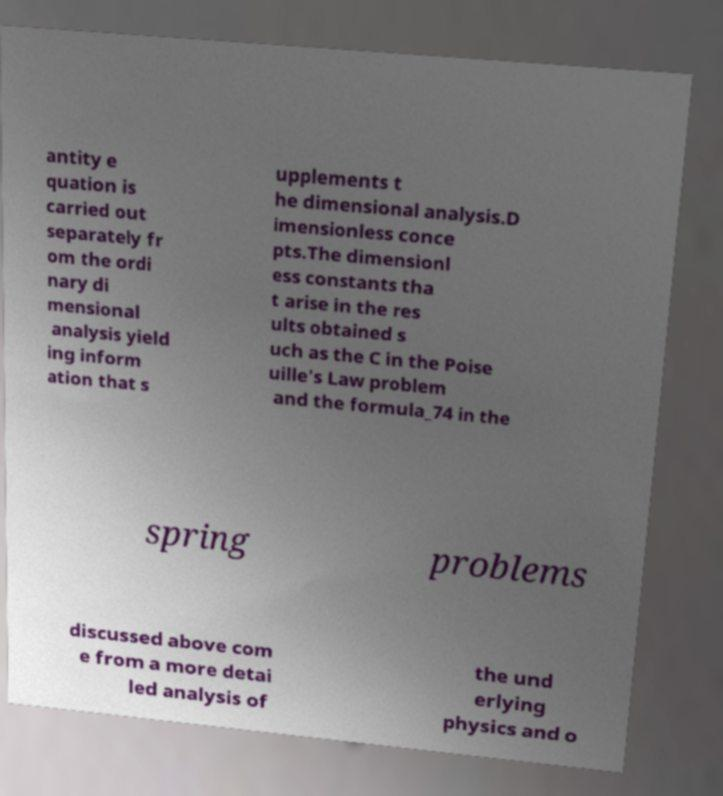Please read and relay the text visible in this image. What does it say? antity e quation is carried out separately fr om the ordi nary di mensional analysis yield ing inform ation that s upplements t he dimensional analysis.D imensionless conce pts.The dimensionl ess constants tha t arise in the res ults obtained s uch as the C in the Poise uille's Law problem and the formula_74 in the spring problems discussed above com e from a more detai led analysis of the und erlying physics and o 